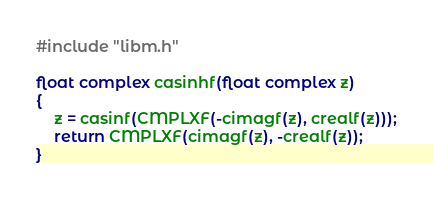<code> <loc_0><loc_0><loc_500><loc_500><_C_>#include "libm.h"

float complex casinhf(float complex z)
{
	z = casinf(CMPLXF(-cimagf(z), crealf(z)));
	return CMPLXF(cimagf(z), -crealf(z));
}
</code> 